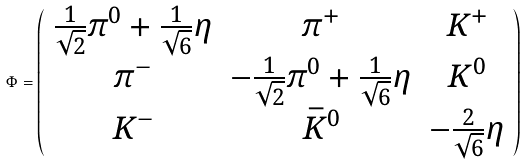Convert formula to latex. <formula><loc_0><loc_0><loc_500><loc_500>\Phi = \left ( \begin{array} { c c c } \frac { 1 } { \sqrt { 2 } } \pi ^ { 0 } + \frac { 1 } { \sqrt { 6 } } \eta & \pi ^ { + } & K ^ { + } \\ \pi ^ { - } & - \frac { 1 } { \sqrt { 2 } } \pi ^ { 0 } + \frac { 1 } { \sqrt { 6 } } \eta & K ^ { 0 } \\ K ^ { - } & \bar { K } ^ { 0 } & - \frac { 2 } { \sqrt { 6 } } \eta \end{array} \right )</formula> 